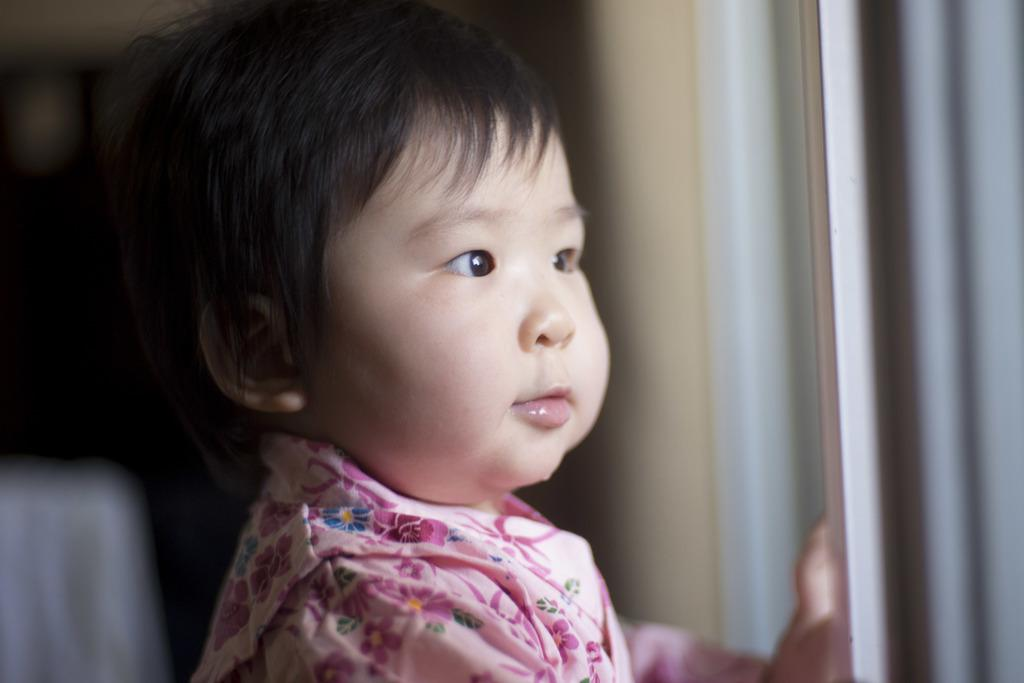Who or what is the main subject in the image? There is a person in the image. What can be observed about the person's attire? The person is wearing a dress with pink, blue, yellow, and green colors. Can you describe the background of the image? The background of the image is blurred. What statement does the person need to make in the image? There is no indication in the image that the person needs to make a statement. 